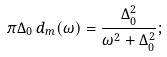<formula> <loc_0><loc_0><loc_500><loc_500>\pi \Delta _ { 0 } \, d _ { m } ( \omega ) = \frac { \Delta _ { 0 } ^ { 2 } } { \omega ^ { 2 } + \Delta _ { 0 } ^ { 2 } } ;</formula> 